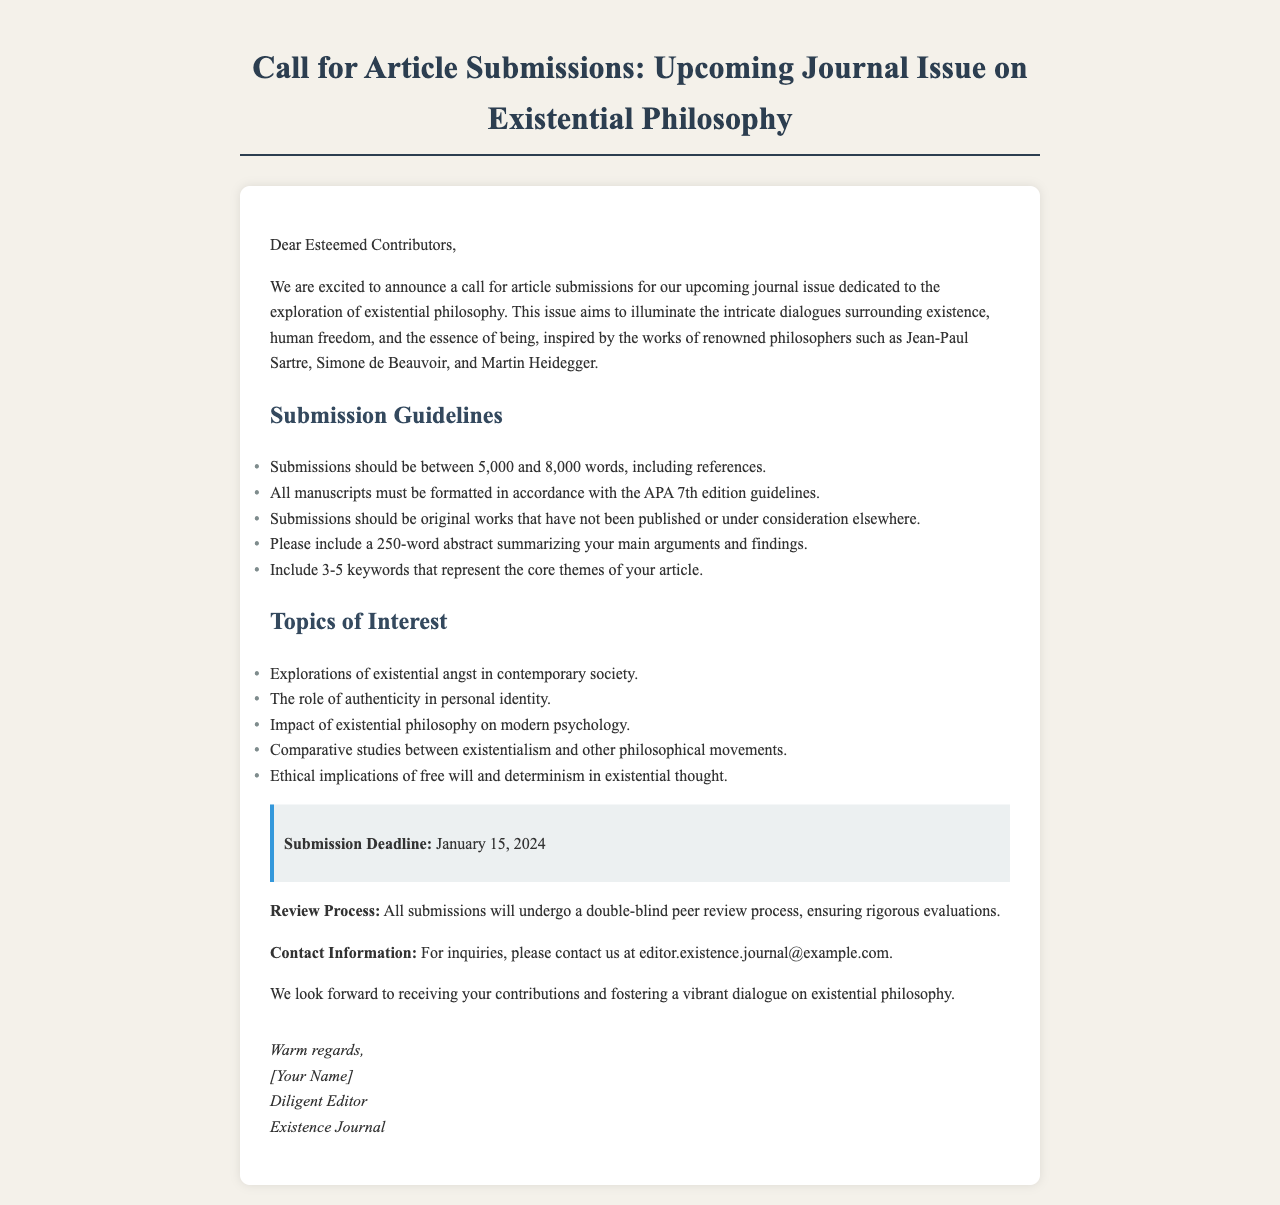What is the submission deadline? The submission deadline is explicitly stated in the document as January 15, 2024.
Answer: January 15, 2024 How many words should the submissions be? The document specifies that submissions should be between 5,000 and 8,000 words, including references.
Answer: 5,000 and 8,000 words What formatting guidelines must be followed? The submission guidelines require that all manuscripts must be formatted in accordance with the APA 7th edition guidelines.
Answer: APA 7th edition What is the main theme of the upcoming journal issue? The main theme of the upcoming journal issue is the exploration of existential philosophy, particularly around existence, human freedom, and the essence of being.
Answer: Existential philosophy How many keywords should be included? The guidelines indicate that submissions should include 3-5 keywords that represent the core themes of the article.
Answer: 3-5 keywords What type of review process will be used? The document states that all submissions will undergo a double-blind peer review process.
Answer: Double-blind peer review What is the contact email provided for inquiries? The contact information section of the document provides the email address for inquiries as editor.existence.journal@example.com.
Answer: editor.existence.journal@example.com Who is the author of the call for submissions? The signature in the document indicates that the author of the call for submissions is referred to as [Your Name], Diligent Editor, Existence Journal.
Answer: [Your Name] 